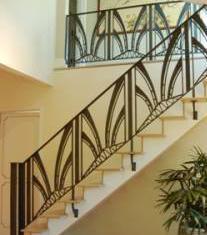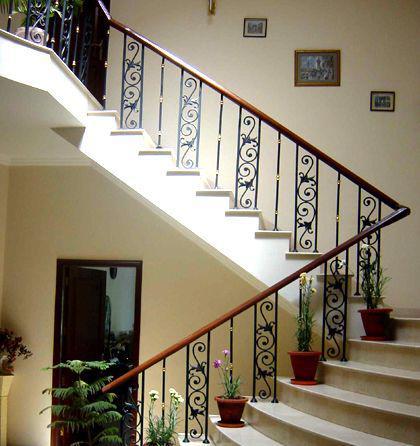The first image is the image on the left, the second image is the image on the right. Analyze the images presented: Is the assertion "The staircase in one of the images spirals its way down." valid? Answer yes or no. No. The first image is the image on the left, the second image is the image on the right. Assess this claim about the two images: "One image features backless stairs that ascend in a spiral pattern from an upright pole in the center.". Correct or not? Answer yes or no. No. 